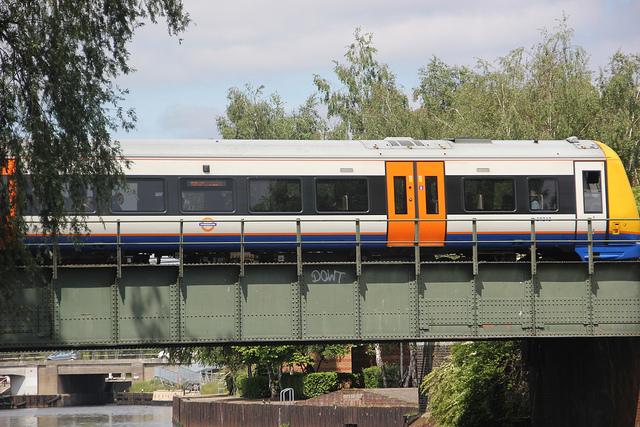What color are the doors on the train?
Give a very brief answer. Orange. What is this mode of transportation?
Answer briefly. Train. What color is the front?
Write a very short answer. Yellow. 